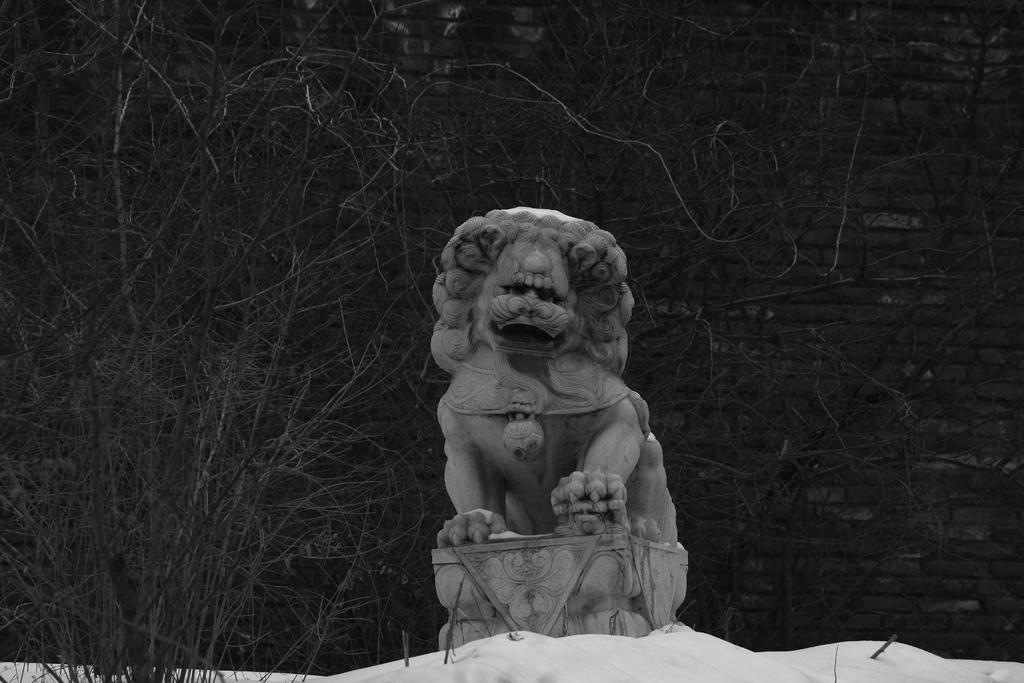How would you summarize this image in a sentence or two? In the middle of the picture, we see the statue in the shape of the lion. Behind that, there are trees. In the background, we see a wall which is made up of bricks. At the bottom, we see the ice. 